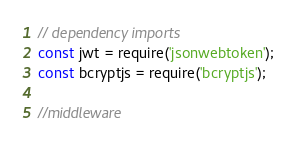Convert code to text. <code><loc_0><loc_0><loc_500><loc_500><_JavaScript_>// dependency imports
const jwt = require('jsonwebtoken');
const bcryptjs = require('bcryptjs');

//middleware</code> 